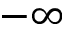<formula> <loc_0><loc_0><loc_500><loc_500>- \infty</formula> 